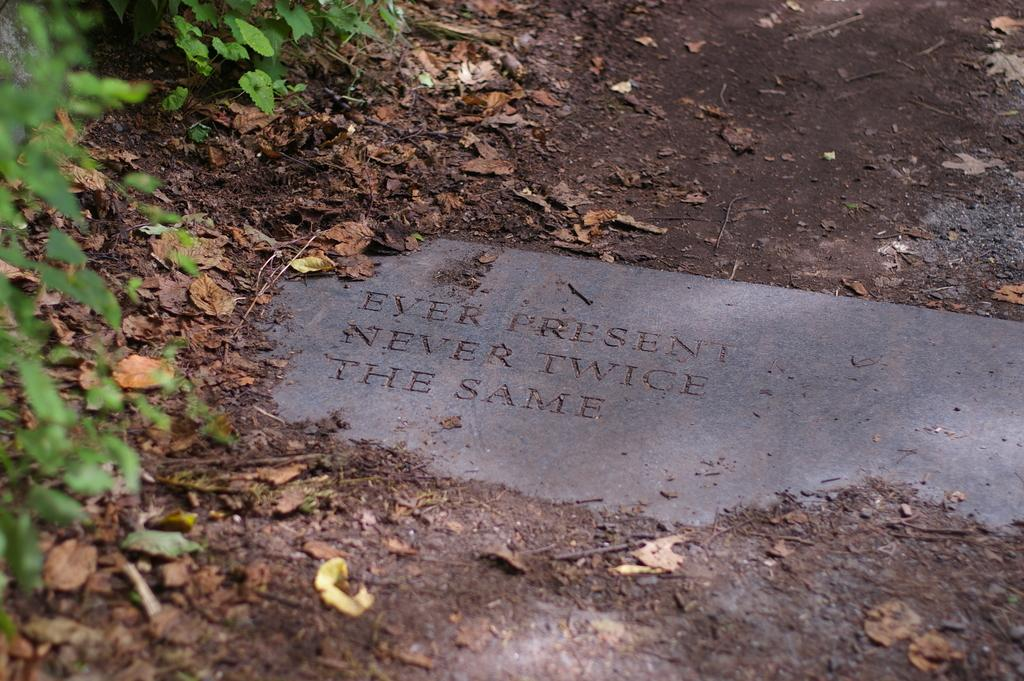What colors can be seen in the leaves in the image? The leaves in the image have green and brown colors. What else can be found in the image besides the leaves? There is something written in the image. How many elbows can be seen in the image? There are no elbows visible in the image. What type of net is used to catch the leaves in the image? There is no net present in the image, and the leaves are not being caught. 